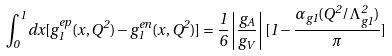Convert formula to latex. <formula><loc_0><loc_0><loc_500><loc_500>\int _ { 0 } ^ { 1 } d x [ g _ { 1 } ^ { e p } ( x , Q ^ { 2 } ) - g _ { 1 } ^ { e n } ( x , Q ^ { 2 } ) ] = \frac { 1 } { 6 } \left | \frac { g _ { A } } { g _ { V } } \right | [ 1 - \frac { \alpha _ { g 1 } ( Q ^ { 2 } / \Lambda ^ { 2 } _ { g 1 } ) } { \pi } ]</formula> 